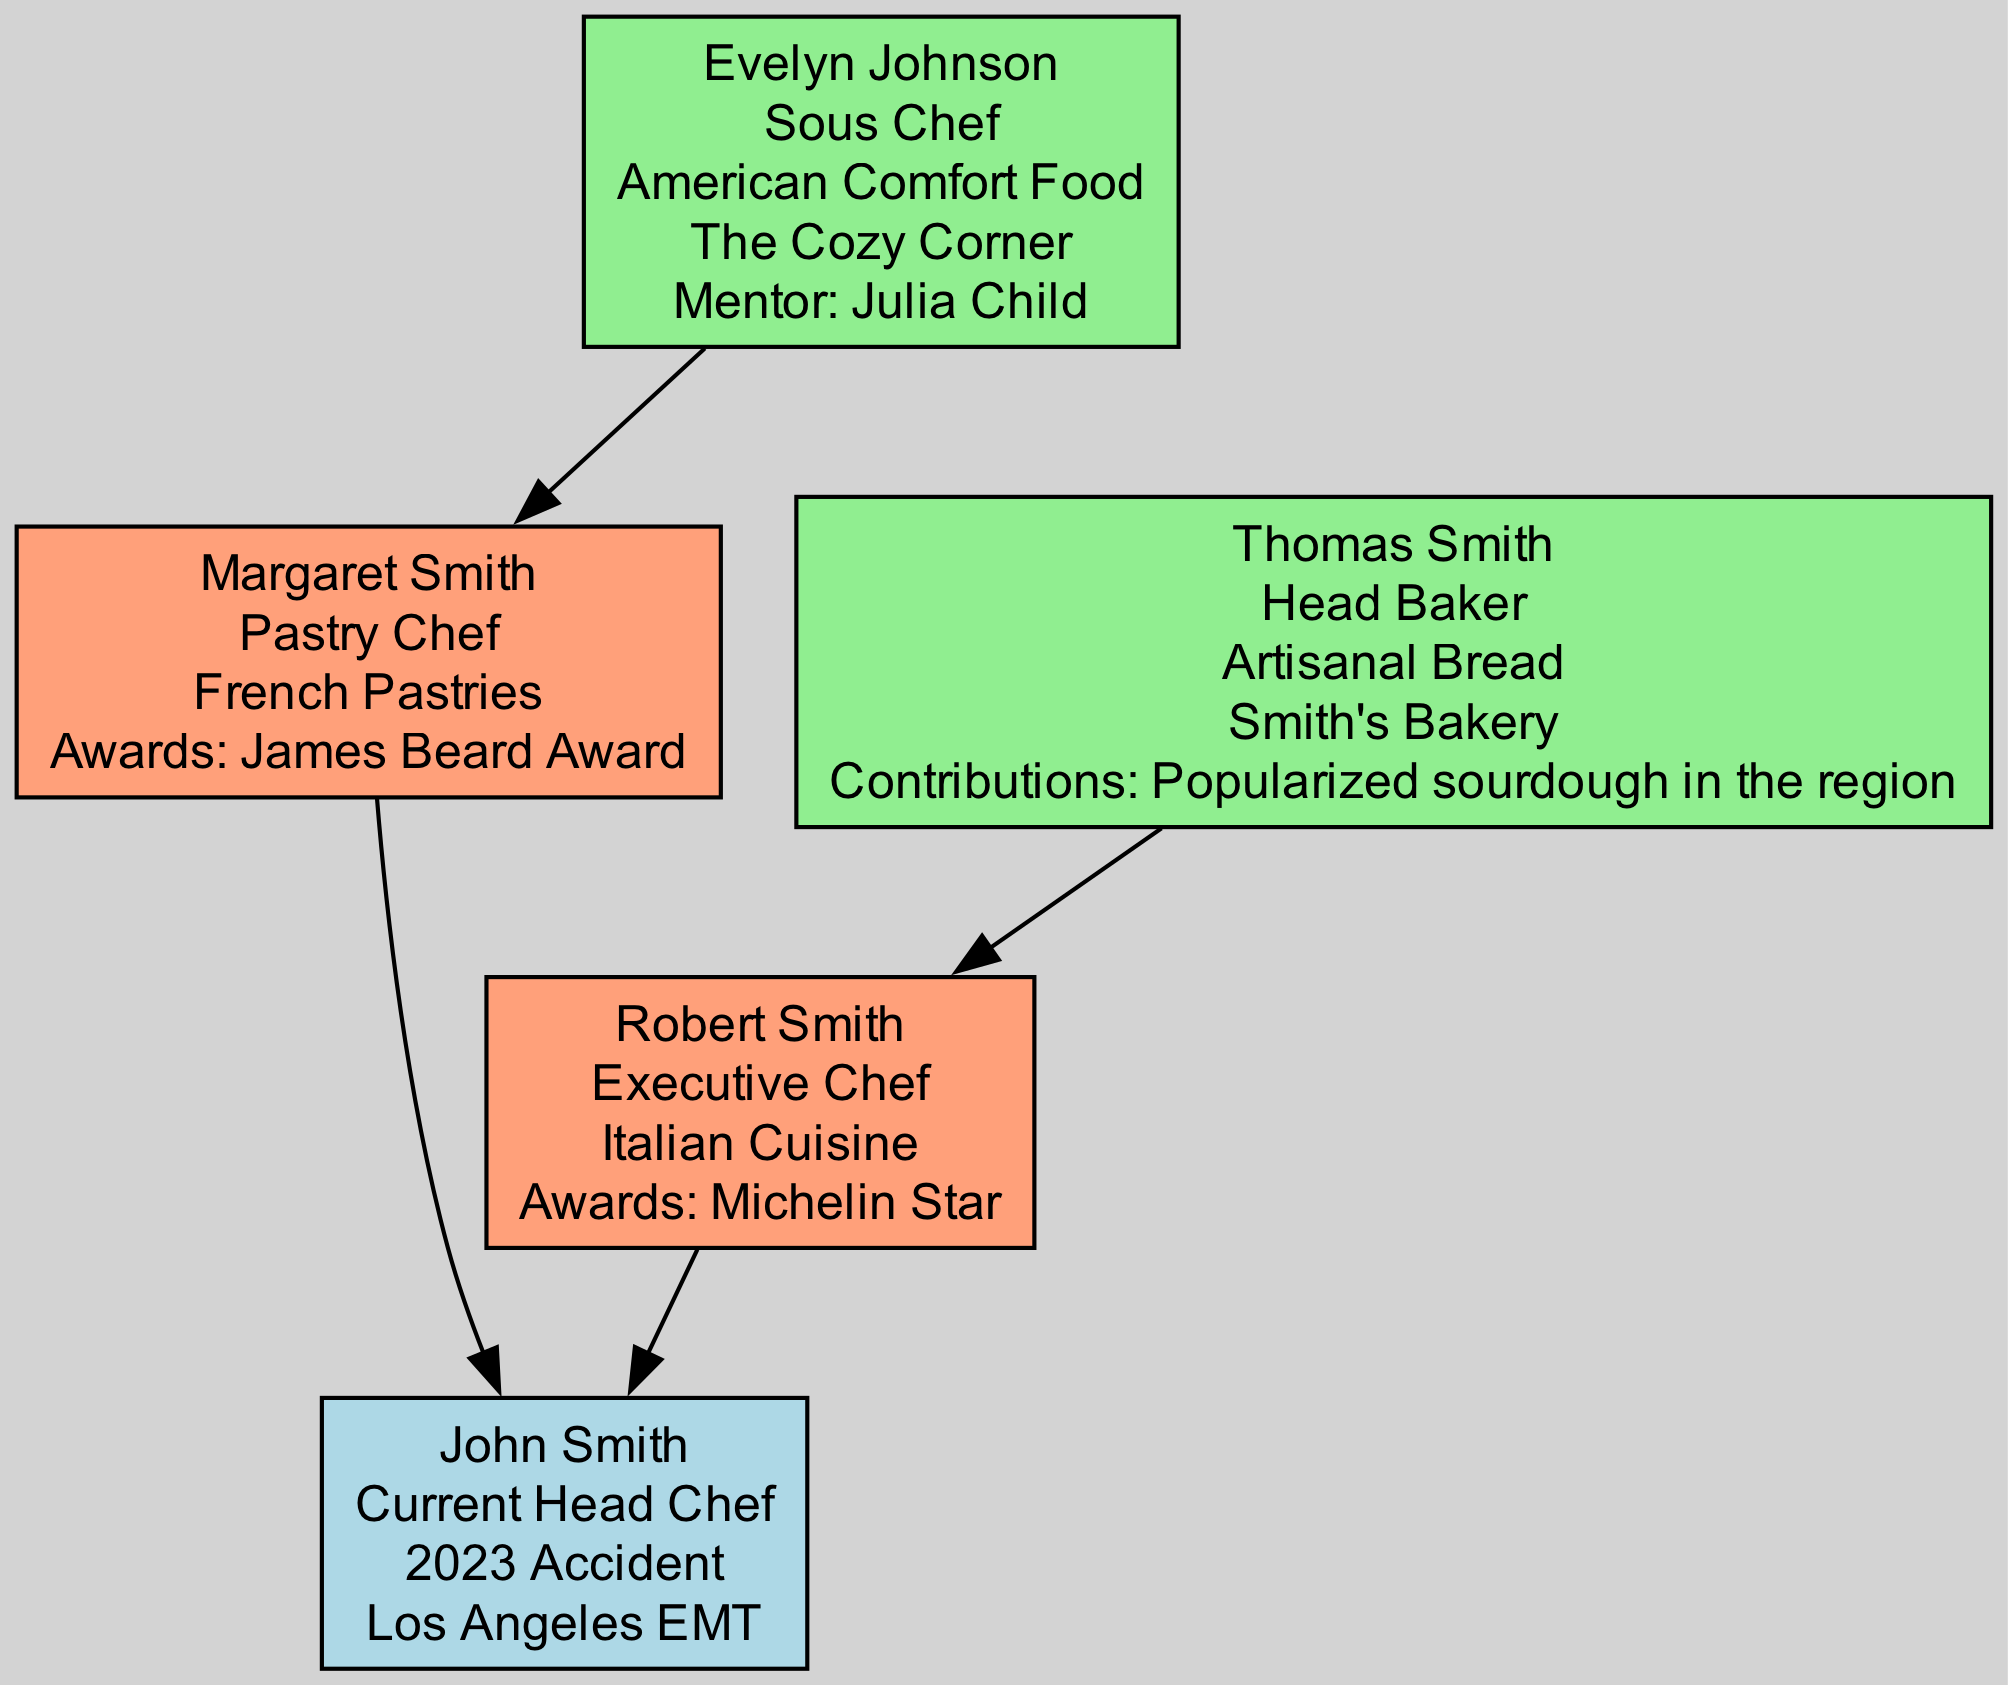What is the role of John Smith? The diagram indicates that John Smith is the "Current Head Chef," which is clearly labeled within his node.
Answer: Current Head Chef Who was Margaret Smith's specialty? Looking at Margaret Smith's node, it states her specialty as "French Pastries."
Answer: French Pastries How many awards does Robert Smith have? The diagram shows that Robert Smith has one award listed, which is the "Michelin Star."
Answer: 1 What establishment is associated with Thomas Smith? In the node for Thomas Smith, it is mentioned that he is associated with "Smith's Bakery."
Answer: Smith's Bakery Which chef's mentor was Julia Child? Referring to Evelyn Johnson's node, it states her mentor was "Julia Child."
Answer: Julia Child Who is the head chef from generation 1? By examining the nodes, Thomas Smith and Evelyn Johnson are both from generation 1, but the question specifies the head chef role. Thus, we focus on identifying the head baker, which is Thomas Smith.
Answer: Thomas Smith What was the relationship between John Smith and Robert Smith? In the diagram, it shows a direct parental edge connecting John Smith to Robert Smith, indicating that Robert Smith is John Smith's father.
Answer: Father What notable contribution did Thomas Smith make? The diagram points out that Thomas Smith contributed by "Popularized sourdough in the region," which is specifically mentioned in his node.
Answer: Popularized sourdough in the region How many generations are present in the family tree? By looking through the nodes, we see representations of three distinct generations: 1 (grandparents), 2 (parents), and 3 (current chef), making a total of three generations.
Answer: 3 